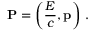<formula> <loc_0><loc_0><loc_500><loc_500>P = \left ( { \frac { E } { c } } , p \right ) \, .</formula> 